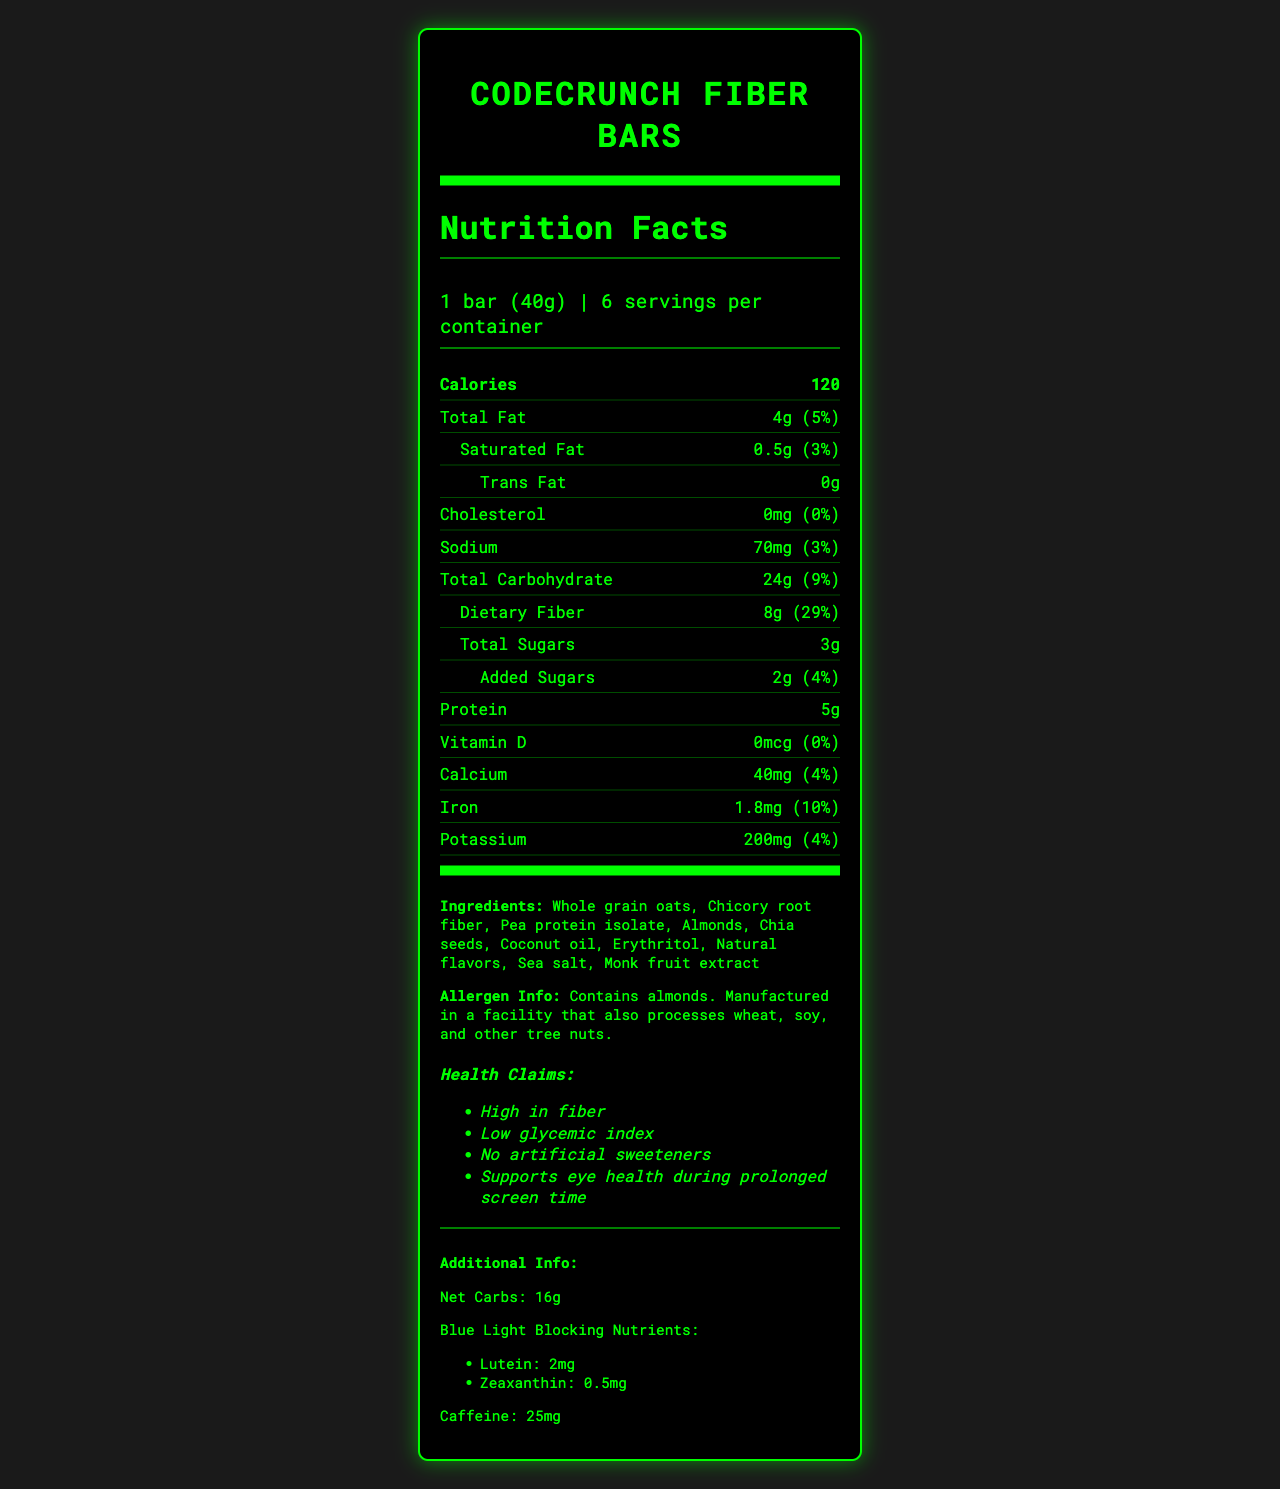what is the serving size for CodeCrunch Fiber Bars? The serving size is stated as "1 bar (40g)" in the serving information section.
Answer: 1 bar (40g) how many calories are in one serving of the CodeCrunch Fiber Bar? The calorie count is listed as "Calories: 120" in a bold section of the nutrition facts.
Answer: 120 what is the amount of dietary fiber per bar? The amount of dietary fiber is given as "Dietary Fiber 8g" under the total carbohydrate section.
Answer: 8g what vitamins are not present in CodeCrunch Fiber Bars? The label shows 0mcg of Vitamin D, indicating its absence in the bars.
Answer: Vitamin D what is the allergen information? The allergen information is found in the ingredients section, stating that the product contains almonds and is manufactured in a facility that also processes wheat, soy, and other tree nuts.
Answer: Contains almonds. Manufactured in a facility that also processes wheat, soy, and other tree nuts. how many grams of total sugars are in one bar? The total sugars amount is stated as "Total Sugars 3g" under the dietary fiber section.
Answer: 3g how much calcium is in one serving? The calcium amount is listed as "Calcium 40mg" under the nutrient section of the label.
Answer: 40mg what are the blue light blocking nutrients included? A. Lutein and Zeaxanthin B. Vitamin A and Vitamin C C. Omega-3 and Omega-6 The document mentions lutein and zeaxanthin specifically for blue light blocking.
Answer: A how many servings are there per container of CodeCrunch Fiber Bars? The serving information states "6 servings per container".
Answer: 6 which item is not an ingredient in CodeCrunch Fiber Bars? A. Erythritol B. Sea salt C. Peanuts The ingredients list includes erythritol and sea salt, but not peanuts.
Answer: C are there any added sugars in the bars? The added sugars are listed as "Added Sugars 2g" under the dietary fiber section.
Answer: Yes does the product contain trans fat? The trans fat amount is listed as "0g", indicating there is no trans fat.
Answer: No what is the protein content of one bar? The protein content is listed as "Protein 5g" under the nutrient section.
Answer: 5g summarize the main idea of the nutrition facts label for CodeCrunch Fiber Bars. The document provides detailed nutrition facts, ingredients, allergen, and health benefits associated with CodeCrunch Fiber Bars.
Answer: CodeCrunch Fiber Bars are a low-sugar, high-fiber snack optimized for screen time with 120 calories per serving. Each bar contains 4g of total fat, 8g of dietary fiber, 3g of total sugars, and 5g of protein. The product is high in fiber, low glycemic, free of artificial sweeteners, and contains nutrients supporting eye health. It has ingredients such as whole grain oats, chicory root fiber, and almonds. are CodeCrunch Fiber Bars manufactured in a gluten-free facility? The document does not provide information on whether the facility is gluten-free.
Answer: Cannot be determined what health benefits are claimed for CodeCrunch Fiber Bars? The health claims are listed near the end of the document in the health claims section.
Answer: High in fiber, Low glycemic index, No artificial sweeteners, Supports eye health during prolonged screen time 